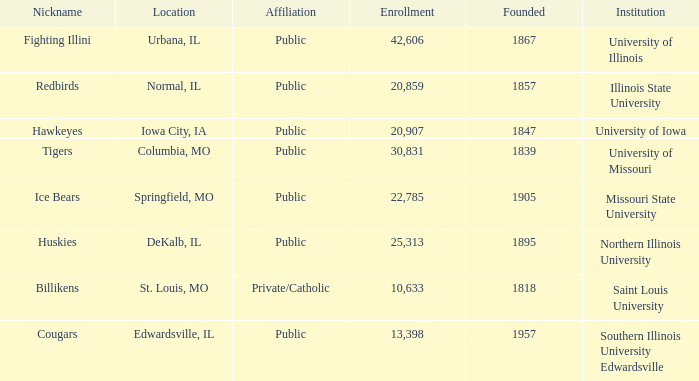What is Southern Illinois University Edwardsville's affiliation? Public. 